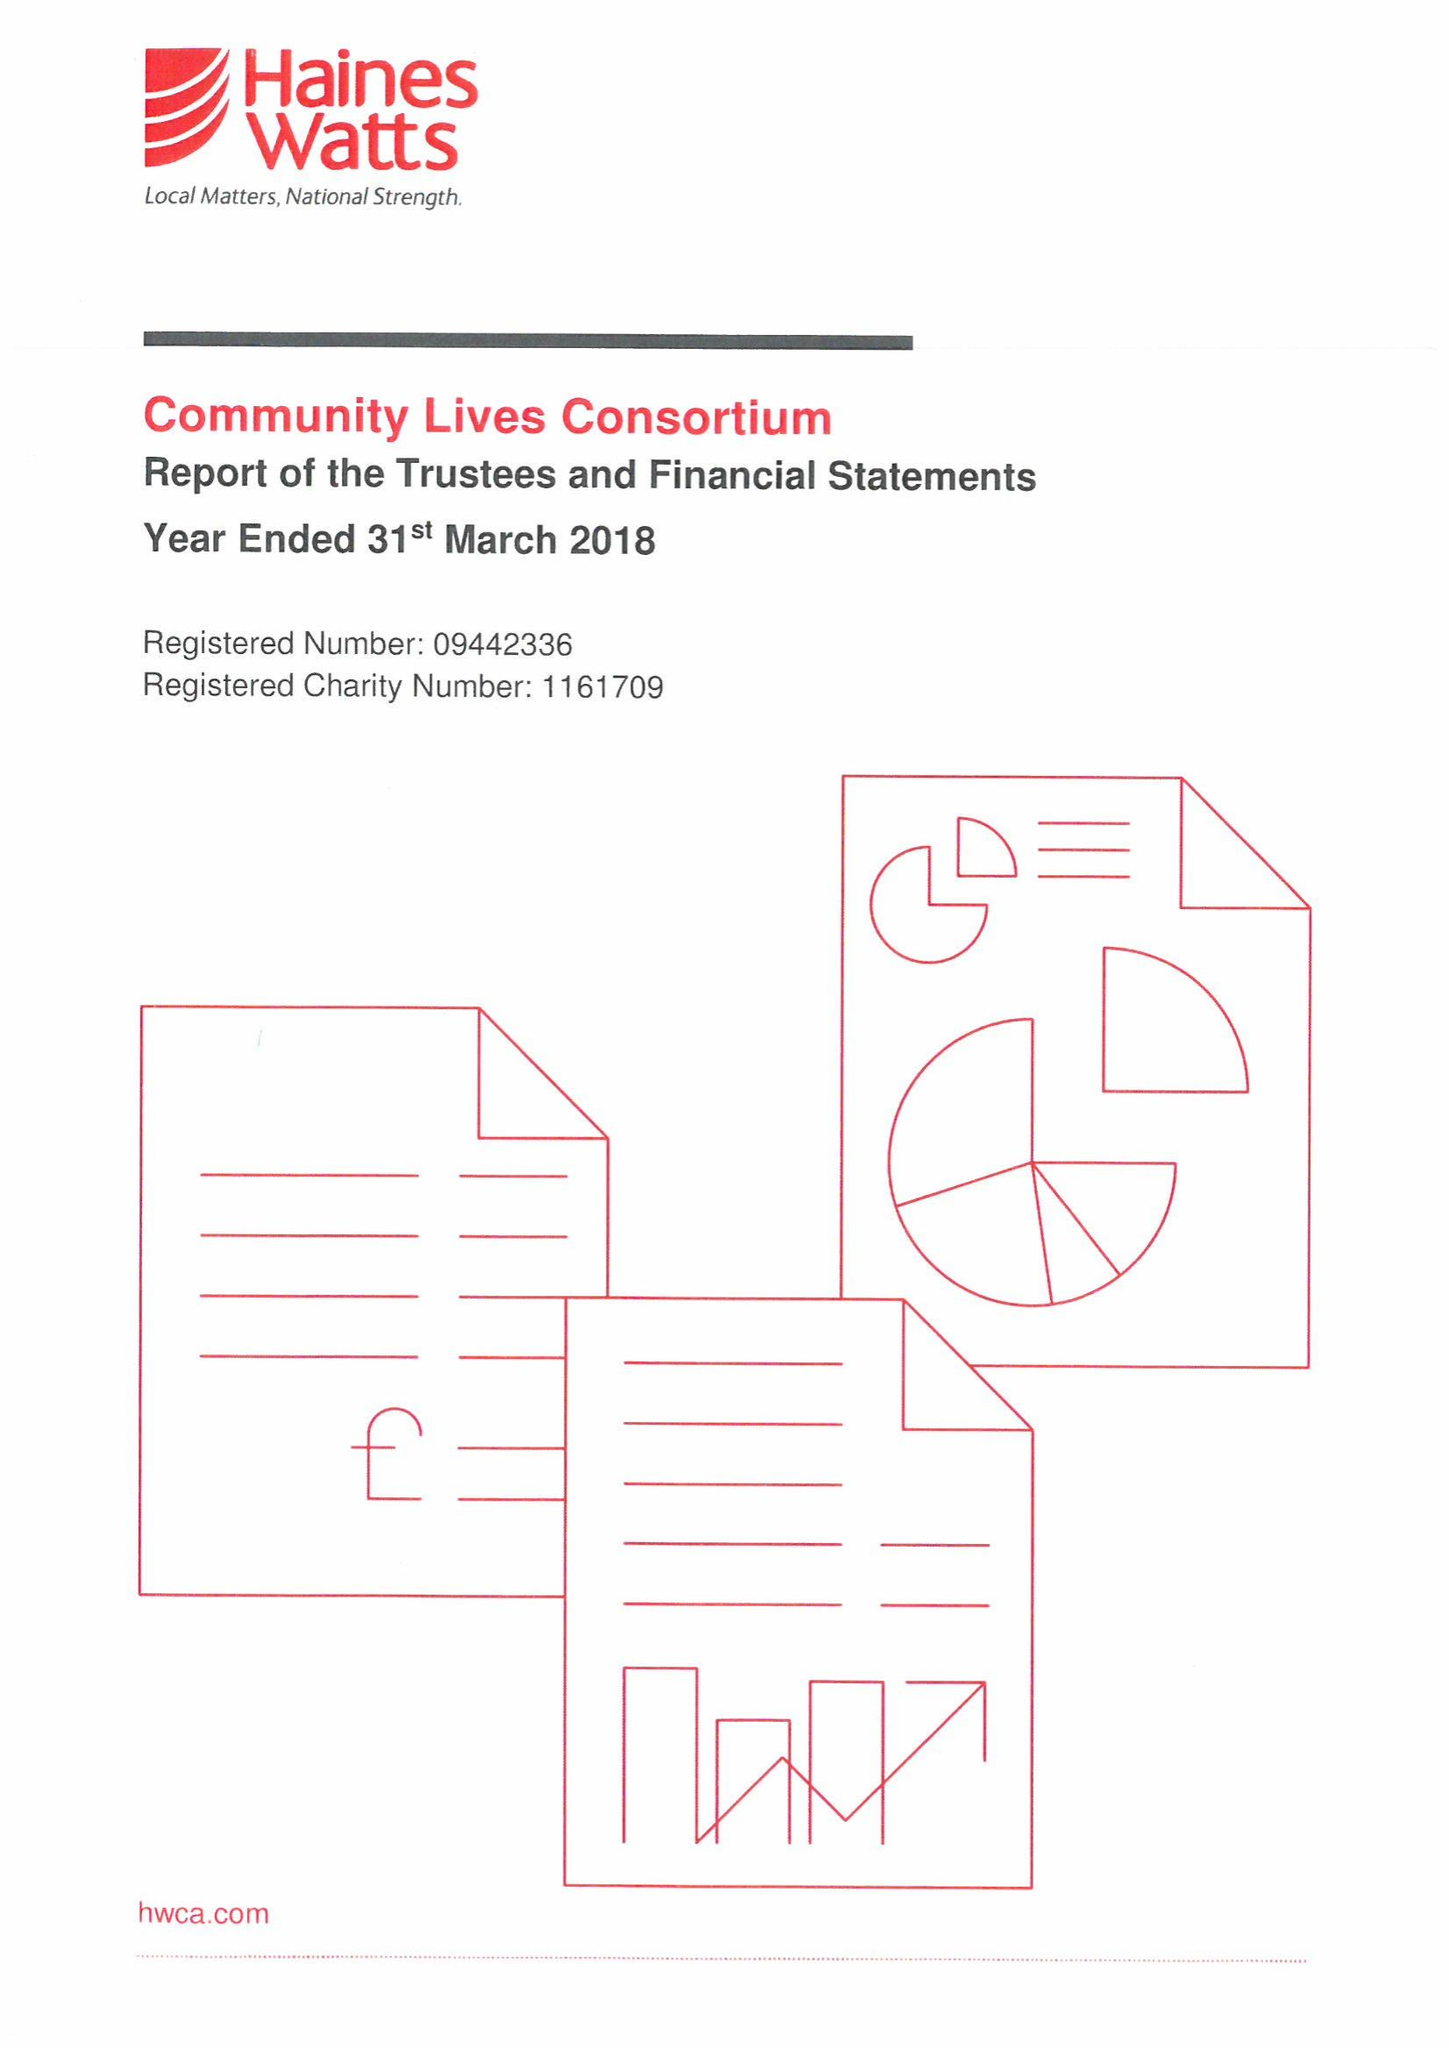What is the value for the charity_number?
Answer the question using a single word or phrase. 1161709 